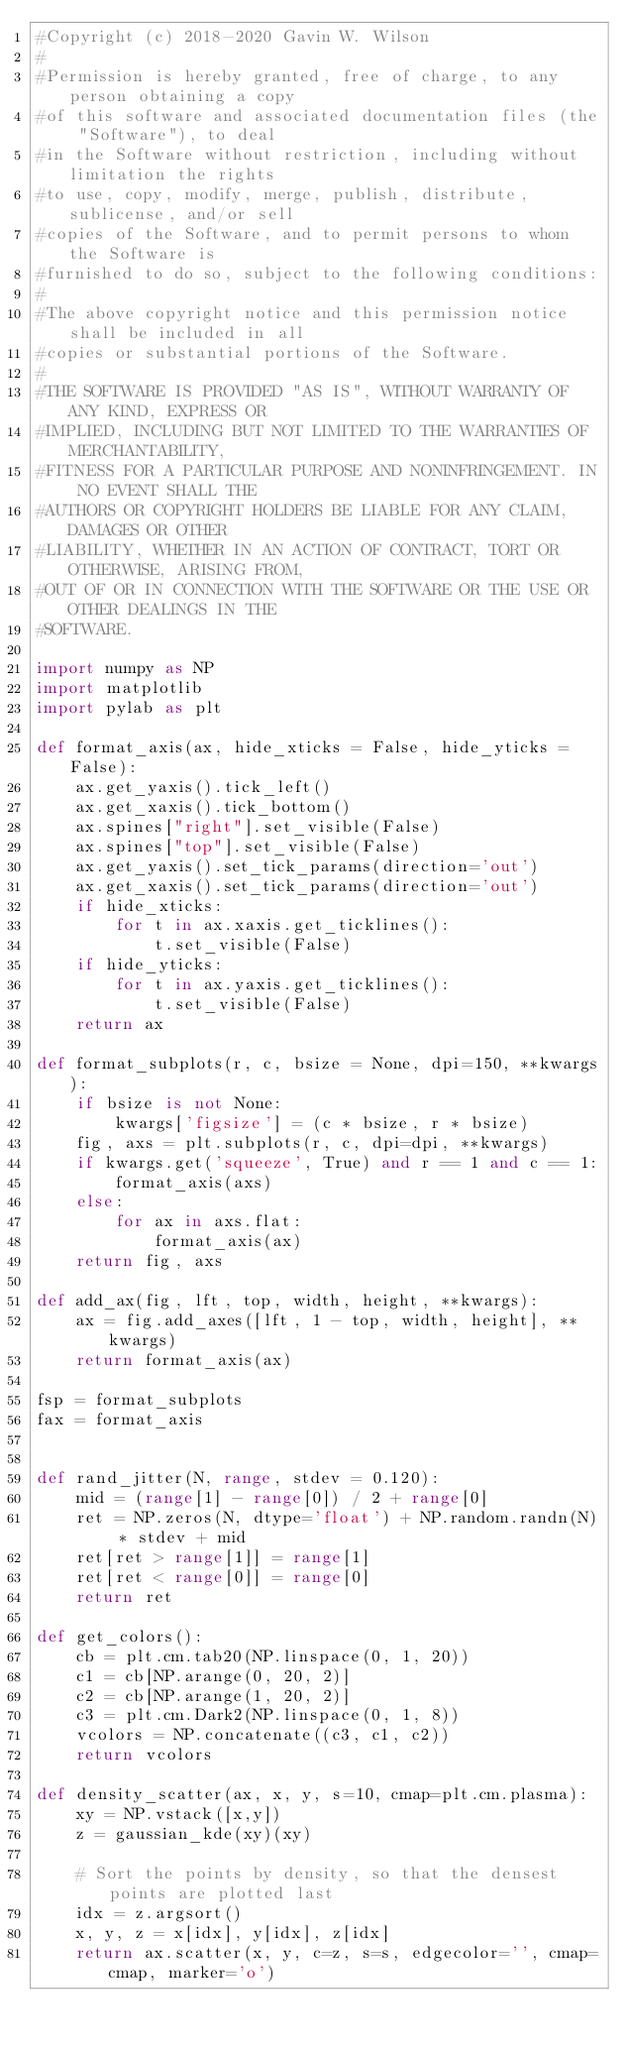Convert code to text. <code><loc_0><loc_0><loc_500><loc_500><_Python_>#Copyright (c) 2018-2020 Gavin W. Wilson
#
#Permission is hereby granted, free of charge, to any person obtaining a copy
#of this software and associated documentation files (the "Software"), to deal
#in the Software without restriction, including without limitation the rights
#to use, copy, modify, merge, publish, distribute, sublicense, and/or sell
#copies of the Software, and to permit persons to whom the Software is
#furnished to do so, subject to the following conditions:
#
#The above copyright notice and this permission notice shall be included in all
#copies or substantial portions of the Software.
#
#THE SOFTWARE IS PROVIDED "AS IS", WITHOUT WARRANTY OF ANY KIND, EXPRESS OR
#IMPLIED, INCLUDING BUT NOT LIMITED TO THE WARRANTIES OF MERCHANTABILITY,
#FITNESS FOR A PARTICULAR PURPOSE AND NONINFRINGEMENT. IN NO EVENT SHALL THE
#AUTHORS OR COPYRIGHT HOLDERS BE LIABLE FOR ANY CLAIM, DAMAGES OR OTHER
#LIABILITY, WHETHER IN AN ACTION OF CONTRACT, TORT OR OTHERWISE, ARISING FROM,
#OUT OF OR IN CONNECTION WITH THE SOFTWARE OR THE USE OR OTHER DEALINGS IN THE
#SOFTWARE.

import numpy as NP
import matplotlib
import pylab as plt

def format_axis(ax, hide_xticks = False, hide_yticks = False):
    ax.get_yaxis().tick_left()
    ax.get_xaxis().tick_bottom()
    ax.spines["right"].set_visible(False)
    ax.spines["top"].set_visible(False)
    ax.get_yaxis().set_tick_params(direction='out')
    ax.get_xaxis().set_tick_params(direction='out')
    if hide_xticks:
        for t in ax.xaxis.get_ticklines(): 
            t.set_visible(False)
    if hide_yticks:
        for t in ax.yaxis.get_ticklines(): 
            t.set_visible(False)
    return ax

def format_subplots(r, c, bsize = None, dpi=150, **kwargs):
    if bsize is not None:
        kwargs['figsize'] = (c * bsize, r * bsize)
    fig, axs = plt.subplots(r, c, dpi=dpi, **kwargs)
    if kwargs.get('squeeze', True) and r == 1 and c == 1:
        format_axis(axs)
    else:
        for ax in axs.flat:
            format_axis(ax)
    return fig, axs

def add_ax(fig, lft, top, width, height, **kwargs):
    ax = fig.add_axes([lft, 1 - top, width, height], **kwargs)
    return format_axis(ax)

fsp = format_subplots
fax = format_axis


def rand_jitter(N, range, stdev = 0.120):
    mid = (range[1] - range[0]) / 2 + range[0]
    ret = NP.zeros(N, dtype='float') + NP.random.randn(N) * stdev + mid
    ret[ret > range[1]] = range[1]
    ret[ret < range[0]] = range[0]
    return ret

def get_colors():
    cb = plt.cm.tab20(NP.linspace(0, 1, 20))
    c1 = cb[NP.arange(0, 20, 2)]
    c2 = cb[NP.arange(1, 20, 2)]
    c3 = plt.cm.Dark2(NP.linspace(0, 1, 8))
    vcolors = NP.concatenate((c3, c1, c2))
    return vcolors

def density_scatter(ax, x, y, s=10, cmap=plt.cm.plasma):
    xy = NP.vstack([x,y])
    z = gaussian_kde(xy)(xy)

    # Sort the points by density, so that the densest points are plotted last
    idx = z.argsort()
    x, y, z = x[idx], y[idx], z[idx]
    return ax.scatter(x, y, c=z, s=s, edgecolor='', cmap=cmap, marker='o')
</code> 